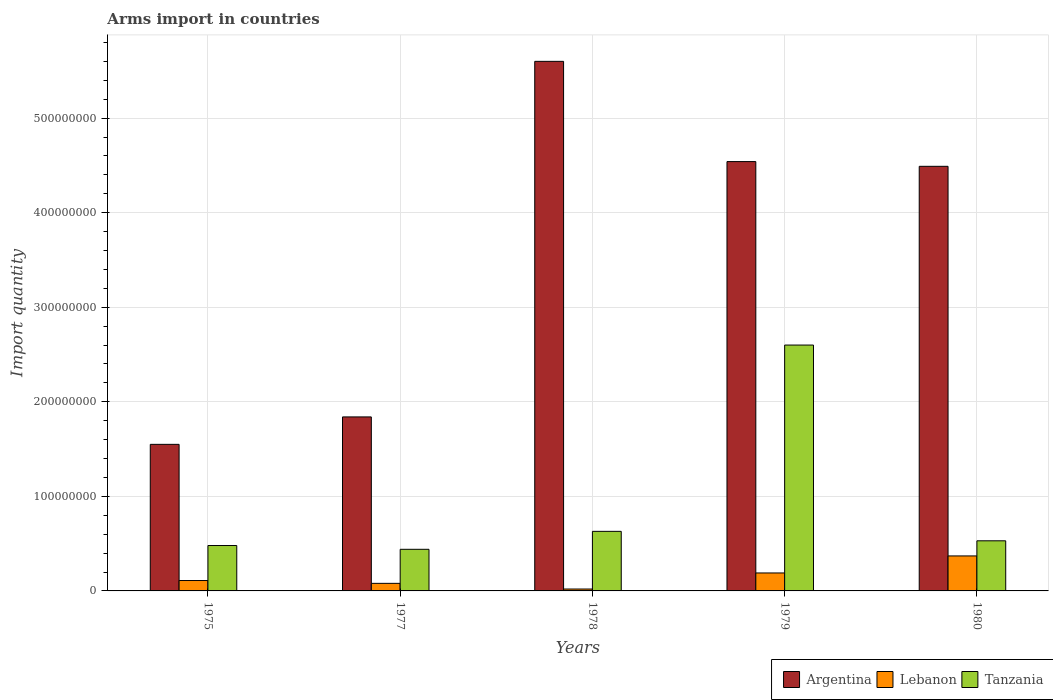How many groups of bars are there?
Offer a very short reply. 5. Are the number of bars on each tick of the X-axis equal?
Ensure brevity in your answer.  Yes. How many bars are there on the 3rd tick from the left?
Offer a very short reply. 3. How many bars are there on the 2nd tick from the right?
Your response must be concise. 3. What is the label of the 1st group of bars from the left?
Offer a very short reply. 1975. What is the total arms import in Argentina in 1980?
Your answer should be very brief. 4.49e+08. Across all years, what is the maximum total arms import in Tanzania?
Give a very brief answer. 2.60e+08. Across all years, what is the minimum total arms import in Tanzania?
Your answer should be compact. 4.40e+07. In which year was the total arms import in Tanzania maximum?
Provide a succinct answer. 1979. In which year was the total arms import in Lebanon minimum?
Offer a terse response. 1978. What is the total total arms import in Argentina in the graph?
Keep it short and to the point. 1.80e+09. What is the difference between the total arms import in Argentina in 1975 and that in 1978?
Provide a short and direct response. -4.05e+08. What is the difference between the total arms import in Tanzania in 1975 and the total arms import in Lebanon in 1978?
Offer a very short reply. 4.60e+07. What is the average total arms import in Tanzania per year?
Offer a very short reply. 9.36e+07. In the year 1980, what is the difference between the total arms import in Tanzania and total arms import in Lebanon?
Your answer should be very brief. 1.60e+07. In how many years, is the total arms import in Tanzania greater than 460000000?
Your response must be concise. 0. What is the ratio of the total arms import in Argentina in 1979 to that in 1980?
Your response must be concise. 1.01. Is the total arms import in Argentina in 1975 less than that in 1979?
Make the answer very short. Yes. What is the difference between the highest and the second highest total arms import in Argentina?
Ensure brevity in your answer.  1.06e+08. What is the difference between the highest and the lowest total arms import in Tanzania?
Your response must be concise. 2.16e+08. In how many years, is the total arms import in Tanzania greater than the average total arms import in Tanzania taken over all years?
Give a very brief answer. 1. Is the sum of the total arms import in Tanzania in 1975 and 1979 greater than the maximum total arms import in Argentina across all years?
Make the answer very short. No. What does the 3rd bar from the left in 1979 represents?
Your answer should be compact. Tanzania. Is it the case that in every year, the sum of the total arms import in Argentina and total arms import in Lebanon is greater than the total arms import in Tanzania?
Your answer should be very brief. Yes. What is the difference between two consecutive major ticks on the Y-axis?
Make the answer very short. 1.00e+08. Where does the legend appear in the graph?
Your answer should be compact. Bottom right. How are the legend labels stacked?
Ensure brevity in your answer.  Horizontal. What is the title of the graph?
Your response must be concise. Arms import in countries. Does "American Samoa" appear as one of the legend labels in the graph?
Provide a short and direct response. No. What is the label or title of the Y-axis?
Provide a short and direct response. Import quantity. What is the Import quantity in Argentina in 1975?
Offer a terse response. 1.55e+08. What is the Import quantity in Lebanon in 1975?
Your response must be concise. 1.10e+07. What is the Import quantity of Tanzania in 1975?
Provide a succinct answer. 4.80e+07. What is the Import quantity of Argentina in 1977?
Offer a very short reply. 1.84e+08. What is the Import quantity in Lebanon in 1977?
Offer a terse response. 8.00e+06. What is the Import quantity in Tanzania in 1977?
Provide a succinct answer. 4.40e+07. What is the Import quantity in Argentina in 1978?
Your answer should be compact. 5.60e+08. What is the Import quantity in Lebanon in 1978?
Offer a terse response. 2.00e+06. What is the Import quantity in Tanzania in 1978?
Give a very brief answer. 6.30e+07. What is the Import quantity in Argentina in 1979?
Make the answer very short. 4.54e+08. What is the Import quantity in Lebanon in 1979?
Offer a very short reply. 1.90e+07. What is the Import quantity in Tanzania in 1979?
Provide a succinct answer. 2.60e+08. What is the Import quantity in Argentina in 1980?
Your response must be concise. 4.49e+08. What is the Import quantity in Lebanon in 1980?
Make the answer very short. 3.70e+07. What is the Import quantity of Tanzania in 1980?
Provide a succinct answer. 5.30e+07. Across all years, what is the maximum Import quantity of Argentina?
Make the answer very short. 5.60e+08. Across all years, what is the maximum Import quantity of Lebanon?
Offer a very short reply. 3.70e+07. Across all years, what is the maximum Import quantity of Tanzania?
Offer a very short reply. 2.60e+08. Across all years, what is the minimum Import quantity in Argentina?
Give a very brief answer. 1.55e+08. Across all years, what is the minimum Import quantity in Tanzania?
Provide a short and direct response. 4.40e+07. What is the total Import quantity in Argentina in the graph?
Ensure brevity in your answer.  1.80e+09. What is the total Import quantity in Lebanon in the graph?
Give a very brief answer. 7.70e+07. What is the total Import quantity in Tanzania in the graph?
Your answer should be very brief. 4.68e+08. What is the difference between the Import quantity in Argentina in 1975 and that in 1977?
Keep it short and to the point. -2.90e+07. What is the difference between the Import quantity in Lebanon in 1975 and that in 1977?
Give a very brief answer. 3.00e+06. What is the difference between the Import quantity of Argentina in 1975 and that in 1978?
Provide a short and direct response. -4.05e+08. What is the difference between the Import quantity of Lebanon in 1975 and that in 1978?
Make the answer very short. 9.00e+06. What is the difference between the Import quantity in Tanzania in 1975 and that in 1978?
Provide a short and direct response. -1.50e+07. What is the difference between the Import quantity in Argentina in 1975 and that in 1979?
Your answer should be very brief. -2.99e+08. What is the difference between the Import quantity of Lebanon in 1975 and that in 1979?
Make the answer very short. -8.00e+06. What is the difference between the Import quantity of Tanzania in 1975 and that in 1979?
Provide a succinct answer. -2.12e+08. What is the difference between the Import quantity of Argentina in 1975 and that in 1980?
Your response must be concise. -2.94e+08. What is the difference between the Import quantity of Lebanon in 1975 and that in 1980?
Offer a very short reply. -2.60e+07. What is the difference between the Import quantity of Tanzania in 1975 and that in 1980?
Give a very brief answer. -5.00e+06. What is the difference between the Import quantity in Argentina in 1977 and that in 1978?
Your answer should be compact. -3.76e+08. What is the difference between the Import quantity in Lebanon in 1977 and that in 1978?
Provide a short and direct response. 6.00e+06. What is the difference between the Import quantity of Tanzania in 1977 and that in 1978?
Your answer should be very brief. -1.90e+07. What is the difference between the Import quantity in Argentina in 1977 and that in 1979?
Provide a short and direct response. -2.70e+08. What is the difference between the Import quantity in Lebanon in 1977 and that in 1979?
Your answer should be compact. -1.10e+07. What is the difference between the Import quantity of Tanzania in 1977 and that in 1979?
Ensure brevity in your answer.  -2.16e+08. What is the difference between the Import quantity of Argentina in 1977 and that in 1980?
Your answer should be very brief. -2.65e+08. What is the difference between the Import quantity of Lebanon in 1977 and that in 1980?
Give a very brief answer. -2.90e+07. What is the difference between the Import quantity of Tanzania in 1977 and that in 1980?
Give a very brief answer. -9.00e+06. What is the difference between the Import quantity in Argentina in 1978 and that in 1979?
Give a very brief answer. 1.06e+08. What is the difference between the Import quantity of Lebanon in 1978 and that in 1979?
Offer a very short reply. -1.70e+07. What is the difference between the Import quantity in Tanzania in 1978 and that in 1979?
Ensure brevity in your answer.  -1.97e+08. What is the difference between the Import quantity in Argentina in 1978 and that in 1980?
Ensure brevity in your answer.  1.11e+08. What is the difference between the Import quantity of Lebanon in 1978 and that in 1980?
Offer a terse response. -3.50e+07. What is the difference between the Import quantity in Lebanon in 1979 and that in 1980?
Give a very brief answer. -1.80e+07. What is the difference between the Import quantity in Tanzania in 1979 and that in 1980?
Your answer should be very brief. 2.07e+08. What is the difference between the Import quantity of Argentina in 1975 and the Import quantity of Lebanon in 1977?
Provide a short and direct response. 1.47e+08. What is the difference between the Import quantity in Argentina in 1975 and the Import quantity in Tanzania in 1977?
Ensure brevity in your answer.  1.11e+08. What is the difference between the Import quantity in Lebanon in 1975 and the Import quantity in Tanzania in 1977?
Your answer should be compact. -3.30e+07. What is the difference between the Import quantity in Argentina in 1975 and the Import quantity in Lebanon in 1978?
Provide a succinct answer. 1.53e+08. What is the difference between the Import quantity of Argentina in 1975 and the Import quantity of Tanzania in 1978?
Ensure brevity in your answer.  9.20e+07. What is the difference between the Import quantity of Lebanon in 1975 and the Import quantity of Tanzania in 1978?
Offer a terse response. -5.20e+07. What is the difference between the Import quantity of Argentina in 1975 and the Import quantity of Lebanon in 1979?
Ensure brevity in your answer.  1.36e+08. What is the difference between the Import quantity in Argentina in 1975 and the Import quantity in Tanzania in 1979?
Your answer should be compact. -1.05e+08. What is the difference between the Import quantity of Lebanon in 1975 and the Import quantity of Tanzania in 1979?
Offer a terse response. -2.49e+08. What is the difference between the Import quantity in Argentina in 1975 and the Import quantity in Lebanon in 1980?
Your response must be concise. 1.18e+08. What is the difference between the Import quantity of Argentina in 1975 and the Import quantity of Tanzania in 1980?
Give a very brief answer. 1.02e+08. What is the difference between the Import quantity of Lebanon in 1975 and the Import quantity of Tanzania in 1980?
Make the answer very short. -4.20e+07. What is the difference between the Import quantity in Argentina in 1977 and the Import quantity in Lebanon in 1978?
Your answer should be very brief. 1.82e+08. What is the difference between the Import quantity of Argentina in 1977 and the Import quantity of Tanzania in 1978?
Your answer should be very brief. 1.21e+08. What is the difference between the Import quantity in Lebanon in 1977 and the Import quantity in Tanzania in 1978?
Your response must be concise. -5.50e+07. What is the difference between the Import quantity in Argentina in 1977 and the Import quantity in Lebanon in 1979?
Offer a very short reply. 1.65e+08. What is the difference between the Import quantity of Argentina in 1977 and the Import quantity of Tanzania in 1979?
Give a very brief answer. -7.60e+07. What is the difference between the Import quantity of Lebanon in 1977 and the Import quantity of Tanzania in 1979?
Give a very brief answer. -2.52e+08. What is the difference between the Import quantity of Argentina in 1977 and the Import quantity of Lebanon in 1980?
Keep it short and to the point. 1.47e+08. What is the difference between the Import quantity in Argentina in 1977 and the Import quantity in Tanzania in 1980?
Give a very brief answer. 1.31e+08. What is the difference between the Import quantity in Lebanon in 1977 and the Import quantity in Tanzania in 1980?
Your response must be concise. -4.50e+07. What is the difference between the Import quantity of Argentina in 1978 and the Import quantity of Lebanon in 1979?
Give a very brief answer. 5.41e+08. What is the difference between the Import quantity in Argentina in 1978 and the Import quantity in Tanzania in 1979?
Give a very brief answer. 3.00e+08. What is the difference between the Import quantity in Lebanon in 1978 and the Import quantity in Tanzania in 1979?
Provide a succinct answer. -2.58e+08. What is the difference between the Import quantity of Argentina in 1978 and the Import quantity of Lebanon in 1980?
Offer a terse response. 5.23e+08. What is the difference between the Import quantity of Argentina in 1978 and the Import quantity of Tanzania in 1980?
Keep it short and to the point. 5.07e+08. What is the difference between the Import quantity in Lebanon in 1978 and the Import quantity in Tanzania in 1980?
Your answer should be very brief. -5.10e+07. What is the difference between the Import quantity of Argentina in 1979 and the Import quantity of Lebanon in 1980?
Your answer should be very brief. 4.17e+08. What is the difference between the Import quantity in Argentina in 1979 and the Import quantity in Tanzania in 1980?
Provide a succinct answer. 4.01e+08. What is the difference between the Import quantity in Lebanon in 1979 and the Import quantity in Tanzania in 1980?
Provide a succinct answer. -3.40e+07. What is the average Import quantity of Argentina per year?
Ensure brevity in your answer.  3.60e+08. What is the average Import quantity of Lebanon per year?
Offer a very short reply. 1.54e+07. What is the average Import quantity of Tanzania per year?
Your answer should be compact. 9.36e+07. In the year 1975, what is the difference between the Import quantity in Argentina and Import quantity in Lebanon?
Keep it short and to the point. 1.44e+08. In the year 1975, what is the difference between the Import quantity in Argentina and Import quantity in Tanzania?
Ensure brevity in your answer.  1.07e+08. In the year 1975, what is the difference between the Import quantity of Lebanon and Import quantity of Tanzania?
Your answer should be compact. -3.70e+07. In the year 1977, what is the difference between the Import quantity in Argentina and Import quantity in Lebanon?
Give a very brief answer. 1.76e+08. In the year 1977, what is the difference between the Import quantity in Argentina and Import quantity in Tanzania?
Provide a succinct answer. 1.40e+08. In the year 1977, what is the difference between the Import quantity in Lebanon and Import quantity in Tanzania?
Ensure brevity in your answer.  -3.60e+07. In the year 1978, what is the difference between the Import quantity of Argentina and Import quantity of Lebanon?
Provide a short and direct response. 5.58e+08. In the year 1978, what is the difference between the Import quantity of Argentina and Import quantity of Tanzania?
Ensure brevity in your answer.  4.97e+08. In the year 1978, what is the difference between the Import quantity in Lebanon and Import quantity in Tanzania?
Keep it short and to the point. -6.10e+07. In the year 1979, what is the difference between the Import quantity in Argentina and Import quantity in Lebanon?
Give a very brief answer. 4.35e+08. In the year 1979, what is the difference between the Import quantity of Argentina and Import quantity of Tanzania?
Make the answer very short. 1.94e+08. In the year 1979, what is the difference between the Import quantity in Lebanon and Import quantity in Tanzania?
Provide a succinct answer. -2.41e+08. In the year 1980, what is the difference between the Import quantity of Argentina and Import quantity of Lebanon?
Offer a very short reply. 4.12e+08. In the year 1980, what is the difference between the Import quantity of Argentina and Import quantity of Tanzania?
Provide a succinct answer. 3.96e+08. In the year 1980, what is the difference between the Import quantity of Lebanon and Import quantity of Tanzania?
Offer a very short reply. -1.60e+07. What is the ratio of the Import quantity in Argentina in 1975 to that in 1977?
Make the answer very short. 0.84. What is the ratio of the Import quantity of Lebanon in 1975 to that in 1977?
Provide a short and direct response. 1.38. What is the ratio of the Import quantity in Argentina in 1975 to that in 1978?
Your answer should be very brief. 0.28. What is the ratio of the Import quantity in Tanzania in 1975 to that in 1978?
Make the answer very short. 0.76. What is the ratio of the Import quantity of Argentina in 1975 to that in 1979?
Offer a very short reply. 0.34. What is the ratio of the Import quantity in Lebanon in 1975 to that in 1979?
Offer a very short reply. 0.58. What is the ratio of the Import quantity in Tanzania in 1975 to that in 1979?
Your answer should be very brief. 0.18. What is the ratio of the Import quantity in Argentina in 1975 to that in 1980?
Offer a very short reply. 0.35. What is the ratio of the Import quantity in Lebanon in 1975 to that in 1980?
Ensure brevity in your answer.  0.3. What is the ratio of the Import quantity in Tanzania in 1975 to that in 1980?
Your answer should be compact. 0.91. What is the ratio of the Import quantity in Argentina in 1977 to that in 1978?
Your answer should be very brief. 0.33. What is the ratio of the Import quantity in Lebanon in 1977 to that in 1978?
Provide a short and direct response. 4. What is the ratio of the Import quantity of Tanzania in 1977 to that in 1978?
Provide a succinct answer. 0.7. What is the ratio of the Import quantity in Argentina in 1977 to that in 1979?
Your answer should be very brief. 0.41. What is the ratio of the Import quantity of Lebanon in 1977 to that in 1979?
Ensure brevity in your answer.  0.42. What is the ratio of the Import quantity in Tanzania in 1977 to that in 1979?
Your answer should be very brief. 0.17. What is the ratio of the Import quantity of Argentina in 1977 to that in 1980?
Offer a very short reply. 0.41. What is the ratio of the Import quantity of Lebanon in 1977 to that in 1980?
Your response must be concise. 0.22. What is the ratio of the Import quantity of Tanzania in 1977 to that in 1980?
Provide a short and direct response. 0.83. What is the ratio of the Import quantity in Argentina in 1978 to that in 1979?
Offer a terse response. 1.23. What is the ratio of the Import quantity of Lebanon in 1978 to that in 1979?
Provide a succinct answer. 0.11. What is the ratio of the Import quantity of Tanzania in 1978 to that in 1979?
Provide a short and direct response. 0.24. What is the ratio of the Import quantity in Argentina in 1978 to that in 1980?
Ensure brevity in your answer.  1.25. What is the ratio of the Import quantity of Lebanon in 1978 to that in 1980?
Ensure brevity in your answer.  0.05. What is the ratio of the Import quantity in Tanzania in 1978 to that in 1980?
Offer a terse response. 1.19. What is the ratio of the Import quantity of Argentina in 1979 to that in 1980?
Provide a succinct answer. 1.01. What is the ratio of the Import quantity in Lebanon in 1979 to that in 1980?
Provide a succinct answer. 0.51. What is the ratio of the Import quantity of Tanzania in 1979 to that in 1980?
Offer a terse response. 4.91. What is the difference between the highest and the second highest Import quantity of Argentina?
Offer a terse response. 1.06e+08. What is the difference between the highest and the second highest Import quantity in Lebanon?
Give a very brief answer. 1.80e+07. What is the difference between the highest and the second highest Import quantity in Tanzania?
Keep it short and to the point. 1.97e+08. What is the difference between the highest and the lowest Import quantity of Argentina?
Provide a succinct answer. 4.05e+08. What is the difference between the highest and the lowest Import quantity of Lebanon?
Give a very brief answer. 3.50e+07. What is the difference between the highest and the lowest Import quantity of Tanzania?
Offer a very short reply. 2.16e+08. 